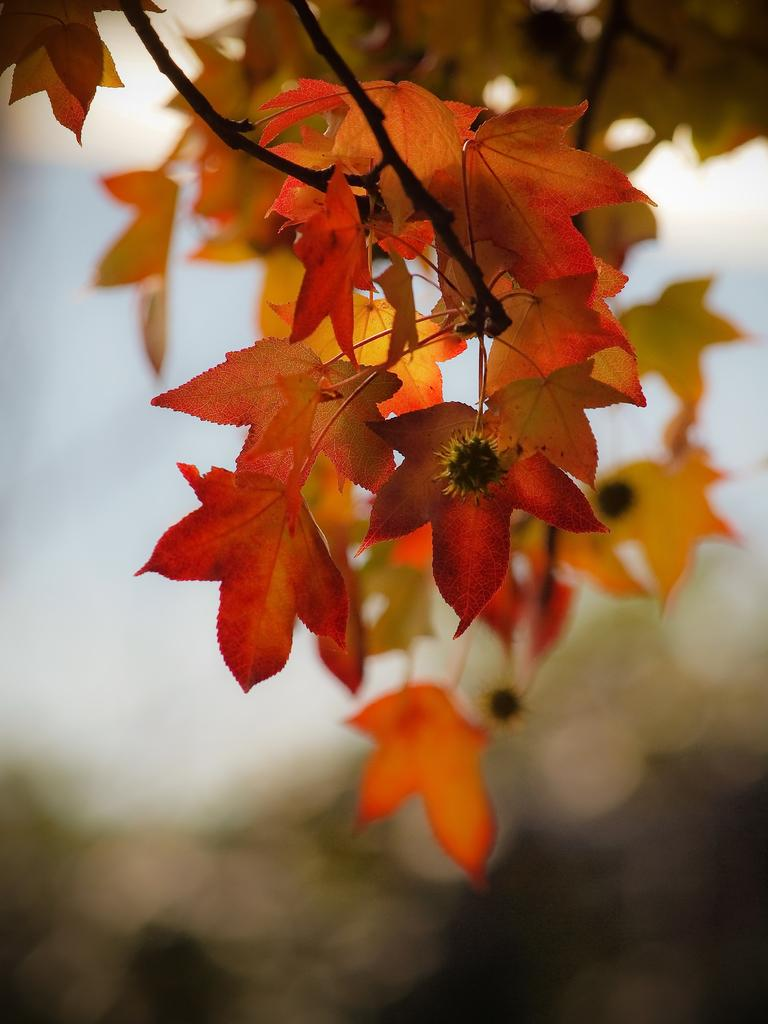What type of plants can be seen in the image? There are flowers and leaves in the image. Can you describe the background of the image? The background of the image is blurred. What type of spoon is used to express hate in the image? There is no spoon or expression of hate present in the image. 